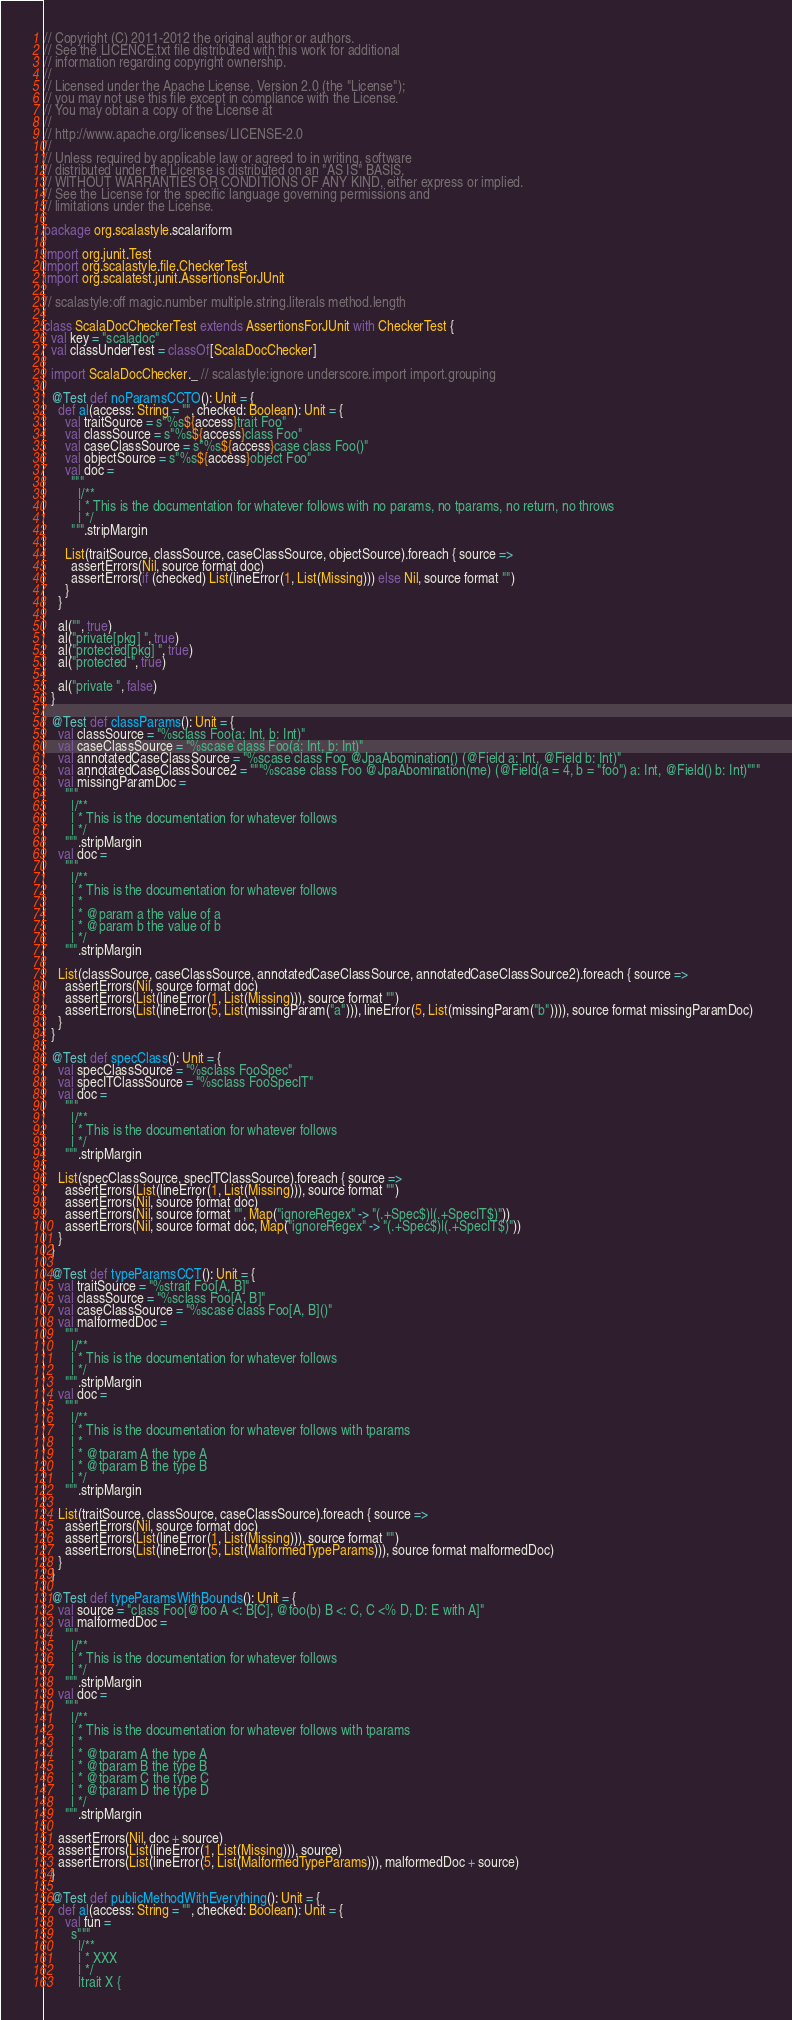<code> <loc_0><loc_0><loc_500><loc_500><_Scala_>// Copyright (C) 2011-2012 the original author or authors.
// See the LICENCE.txt file distributed with this work for additional
// information regarding copyright ownership.
//
// Licensed under the Apache License, Version 2.0 (the "License");
// you may not use this file except in compliance with the License.
// You may obtain a copy of the License at
//
// http://www.apache.org/licenses/LICENSE-2.0
//
// Unless required by applicable law or agreed to in writing, software
// distributed under the License is distributed on an "AS IS" BASIS,
// WITHOUT WARRANTIES OR CONDITIONS OF ANY KIND, either express or implied.
// See the License for the specific language governing permissions and
// limitations under the License.

package org.scalastyle.scalariform

import org.junit.Test
import org.scalastyle.file.CheckerTest
import org.scalatest.junit.AssertionsForJUnit

// scalastyle:off magic.number multiple.string.literals method.length

class ScalaDocCheckerTest extends AssertionsForJUnit with CheckerTest {
  val key = "scaladoc"
  val classUnderTest = classOf[ScalaDocChecker]

  import ScalaDocChecker._ // scalastyle:ignore underscore.import import.grouping

  @Test def noParamsCCTO(): Unit = {
    def al(access: String = "", checked: Boolean): Unit = {
      val traitSource = s"%s${access}trait Foo"
      val classSource = s"%s${access}class Foo"
      val caseClassSource = s"%s${access}case class Foo()"
      val objectSource = s"%s${access}object Foo"
      val doc =
        """
          |/**
          | * This is the documentation for whatever follows with no params, no tparams, no return, no throws
          | */
        """.stripMargin

      List(traitSource, classSource, caseClassSource, objectSource).foreach { source =>
        assertErrors(Nil, source format doc)
        assertErrors(if (checked) List(lineError(1, List(Missing))) else Nil, source format "")
      }
    }

    al("", true)
    al("private[pkg] ", true)
    al("protected[pkg] ", true)
    al("protected ", true)

    al("private ", false)
  }

  @Test def classParams(): Unit = {
    val classSource = "%sclass Foo(a: Int, b: Int)"
    val caseClassSource = "%scase class Foo(a: Int, b: Int)"
    val annotatedCaseClassSource = "%scase class Foo @JpaAbomination() (@Field a: Int, @Field b: Int)"
    val annotatedCaseClassSource2 = """%scase class Foo @JpaAbomination(me) (@Field(a = 4, b = "foo") a: Int, @Field() b: Int)"""
    val missingParamDoc =
      """
        |/**
        | * This is the documentation for whatever follows
        | */
      """.stripMargin
    val doc =
      """
        |/**
        | * This is the documentation for whatever follows
        | *
        | * @param a the value of a
        | * @param b the value of b
        | */
      """.stripMargin

    List(classSource, caseClassSource, annotatedCaseClassSource, annotatedCaseClassSource2).foreach { source =>
      assertErrors(Nil, source format doc)
      assertErrors(List(lineError(1, List(Missing))), source format "")
      assertErrors(List(lineError(5, List(missingParam("a"))), lineError(5, List(missingParam("b")))), source format missingParamDoc)
    }
  }

  @Test def specClass(): Unit = {
    val specClassSource = "%sclass FooSpec"
    val specITClassSource = "%sclass FooSpecIT"
    val doc =
      """
        |/**
        | * This is the documentation for whatever follows
        | */
      """.stripMargin

    List(specClassSource, specITClassSource).foreach { source =>
      assertErrors(List(lineError(1, List(Missing))), source format "")
      assertErrors(Nil, source format doc)
      assertErrors(Nil, source format "", Map("ignoreRegex" -> "(.+Spec$)|(.+SpecIT$)"))
      assertErrors(Nil, source format doc, Map("ignoreRegex" -> "(.+Spec$)|(.+SpecIT$)"))
    }
  }

  @Test def typeParamsCCT(): Unit = {
    val traitSource = "%strait Foo[A, B]"
    val classSource = "%sclass Foo[A, B]"
    val caseClassSource = "%scase class Foo[A, B]()"
    val malformedDoc =
      """
        |/**
        | * This is the documentation for whatever follows
        | */
      """.stripMargin
    val doc =
      """
        |/**
        | * This is the documentation for whatever follows with tparams
        | *
        | * @tparam A the type A
        | * @tparam B the type B
        | */
      """.stripMargin

    List(traitSource, classSource, caseClassSource).foreach { source =>
      assertErrors(Nil, source format doc)
      assertErrors(List(lineError(1, List(Missing))), source format "")
      assertErrors(List(lineError(5, List(MalformedTypeParams))), source format malformedDoc)
    }
  }

  @Test def typeParamsWithBounds(): Unit = {
    val source = "class Foo[@foo A <: B[C], @foo(b) B <: C, C <% D, D: E with A]"
    val malformedDoc =
      """
        |/**
        | * This is the documentation for whatever follows
        | */
      """.stripMargin
    val doc =
      """
        |/**
        | * This is the documentation for whatever follows with tparams
        | *
        | * @tparam A the type A
        | * @tparam B the type B
        | * @tparam C the type C
        | * @tparam D the type D
        | */
      """.stripMargin

    assertErrors(Nil, doc + source)
    assertErrors(List(lineError(1, List(Missing))), source)
    assertErrors(List(lineError(5, List(MalformedTypeParams))), malformedDoc + source)
  }

  @Test def publicMethodWithEverything(): Unit = {
    def al(access: String = "", checked: Boolean): Unit = {
      val fun =
        s"""
          |/**
          | * XXX
          | */
          |trait X {</code> 